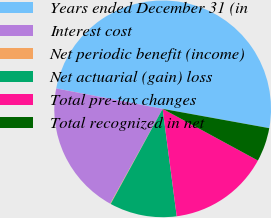<chart> <loc_0><loc_0><loc_500><loc_500><pie_chart><fcel>Years ended December 31 (in<fcel>Interest cost<fcel>Net periodic benefit (income)<fcel>Net actuarial (gain) loss<fcel>Total pre-tax changes<fcel>Total recognized in net<nl><fcel>49.84%<fcel>19.98%<fcel>0.08%<fcel>10.03%<fcel>15.01%<fcel>5.06%<nl></chart> 